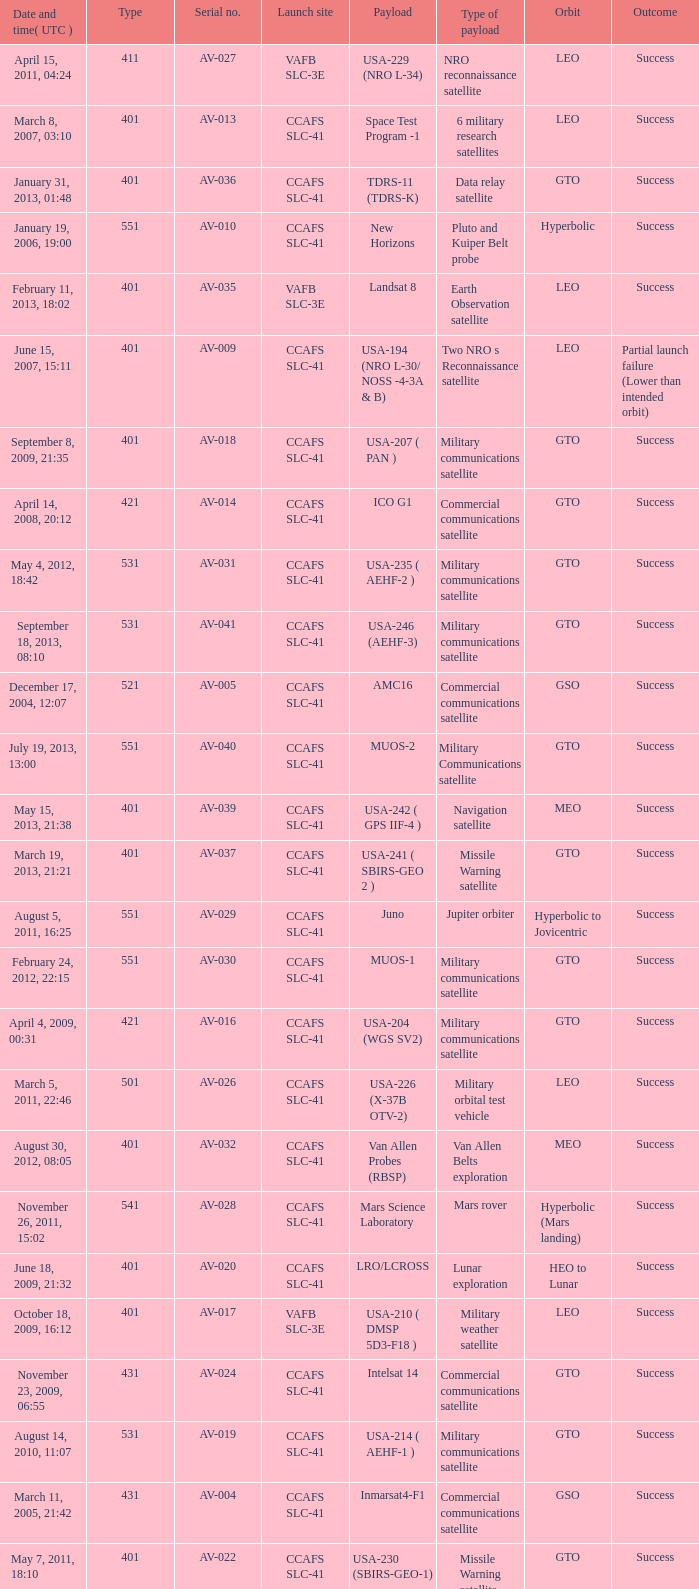When was the payload of Commercial Communications Satellite amc16? December 17, 2004, 12:07. 